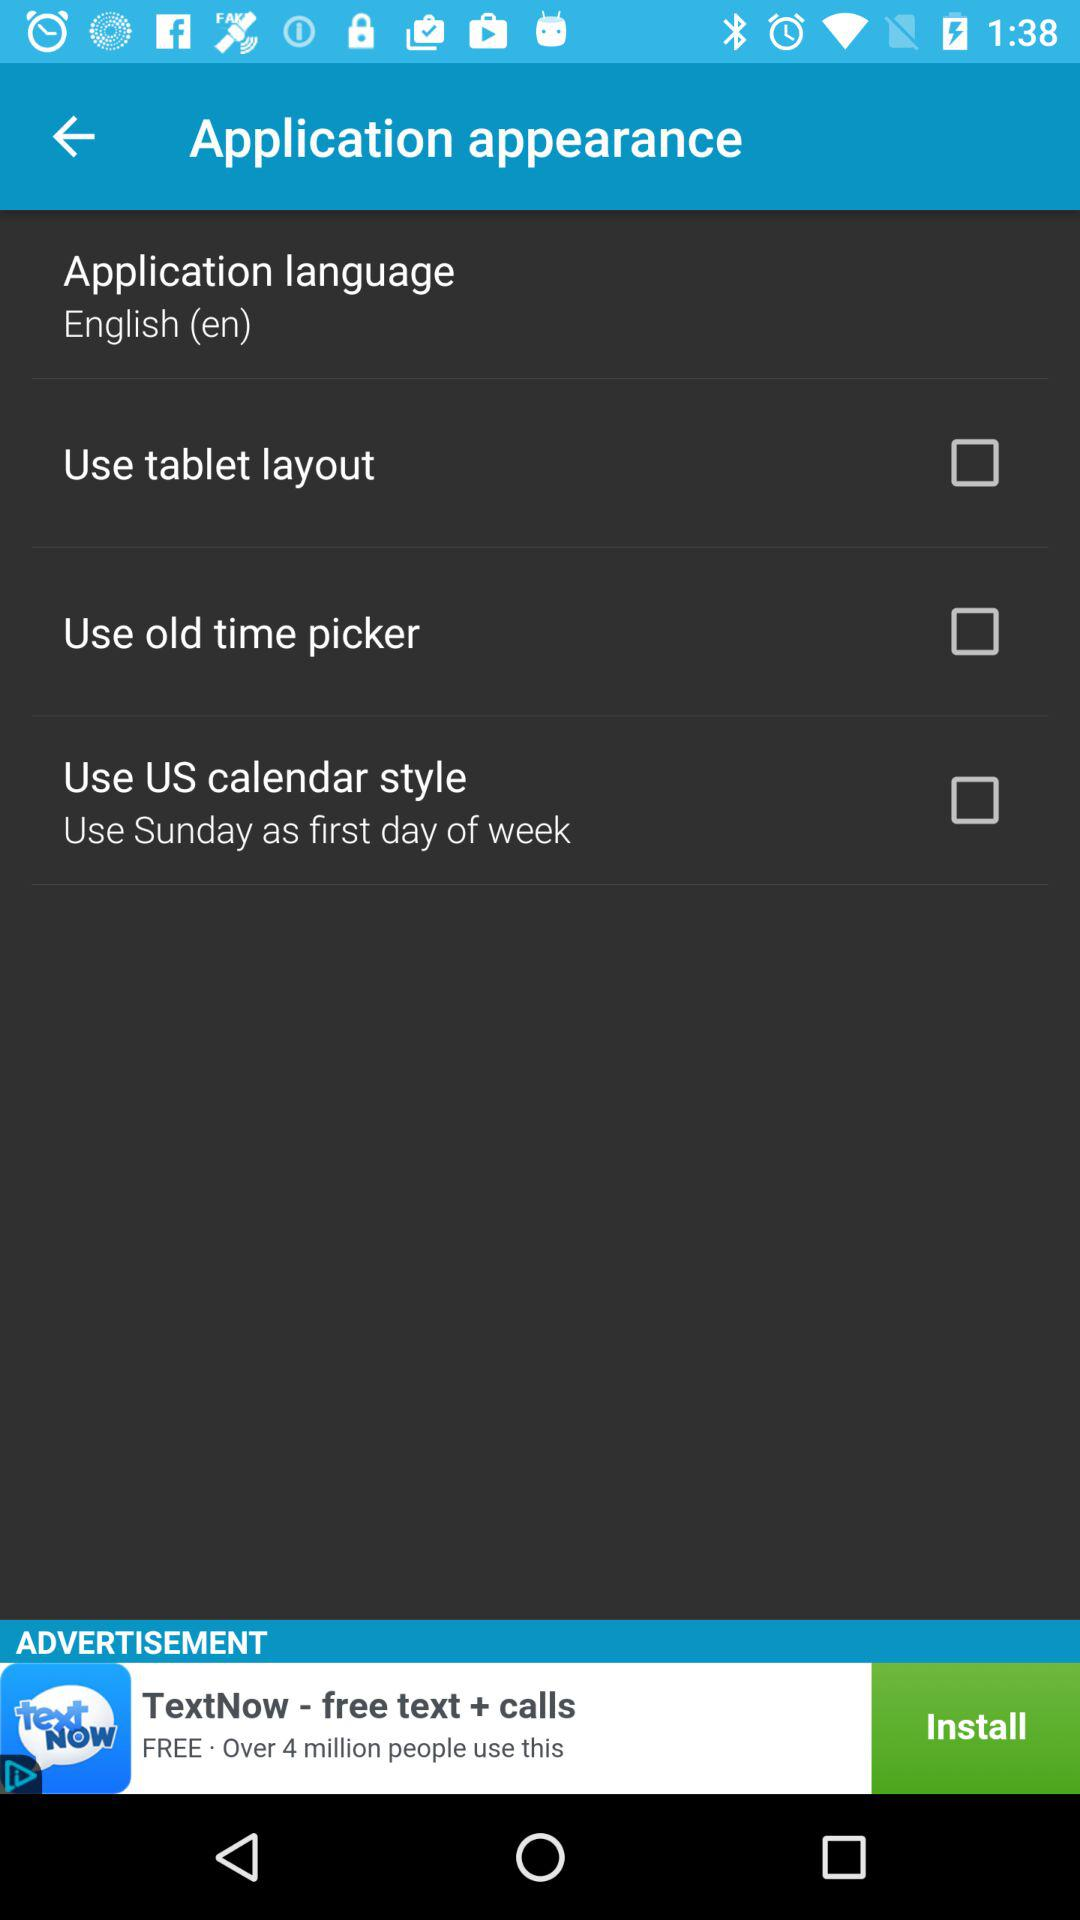Which day is used as the first day of the week? The day used as the first day of the week is Sunday. 